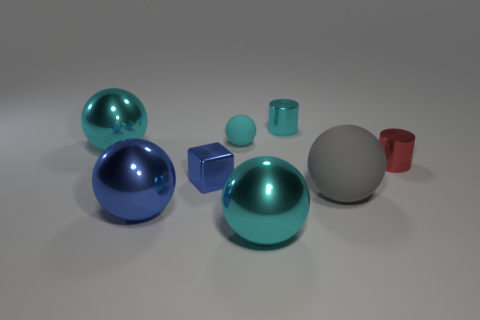Subtract all rubber balls. How many balls are left? 3 Add 1 small cylinders. How many objects exist? 9 Subtract all red cylinders. How many cylinders are left? 1 Subtract all balls. How many objects are left? 3 Subtract all green cylinders. Subtract all gray balls. How many cylinders are left? 2 Add 7 large blue spheres. How many large blue spheres are left? 8 Add 6 tiny blue cubes. How many tiny blue cubes exist? 7 Subtract 1 blue cubes. How many objects are left? 7 Subtract 1 cylinders. How many cylinders are left? 1 Subtract all cyan cubes. How many red cylinders are left? 1 